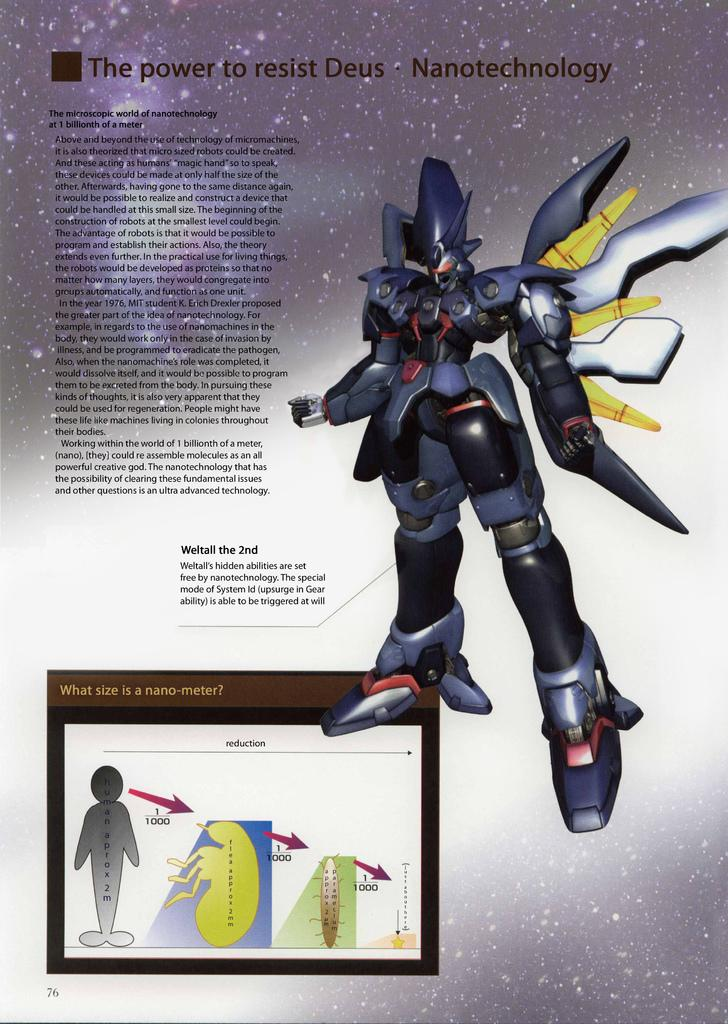Provide a one-sentence caption for the provided image. An article about resisting Deus and Nanotechnology along with a illustration of what is through to be Deus. 